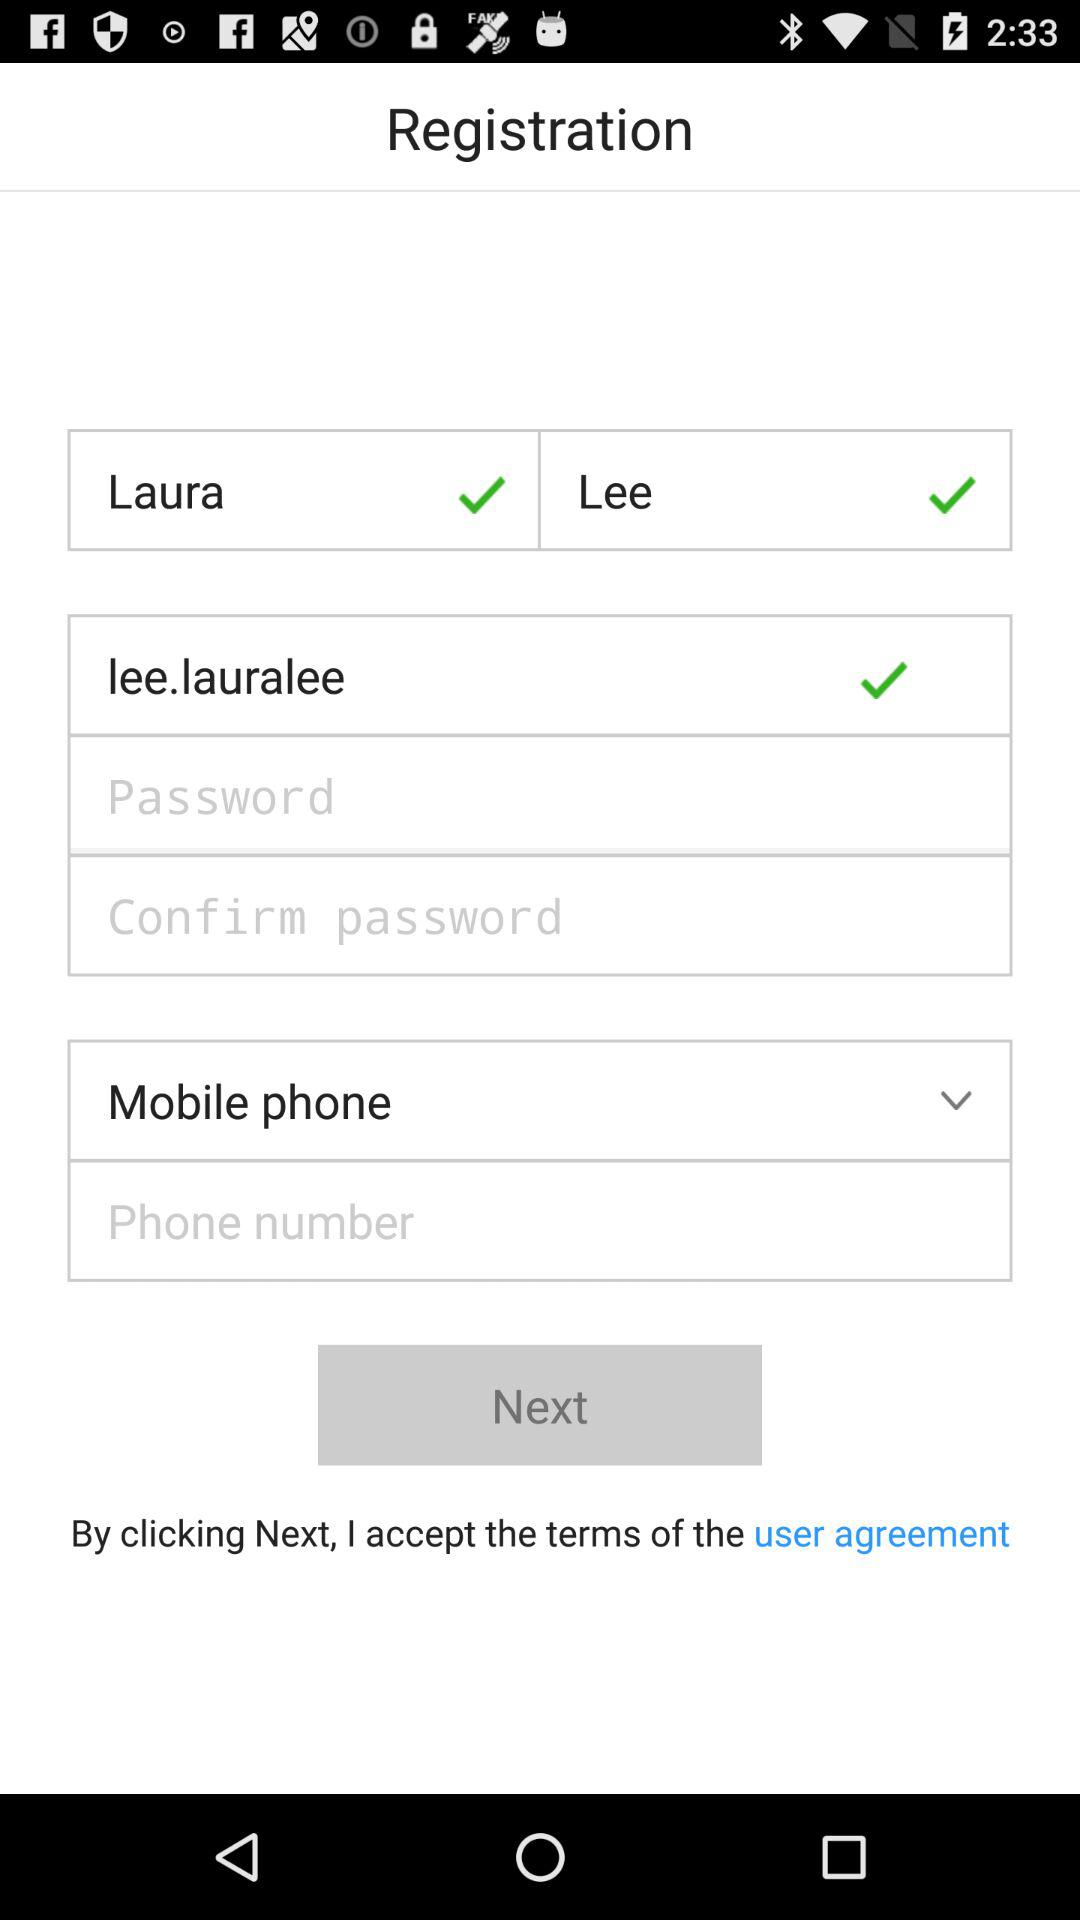What is the name? The name is Laura Lee. 